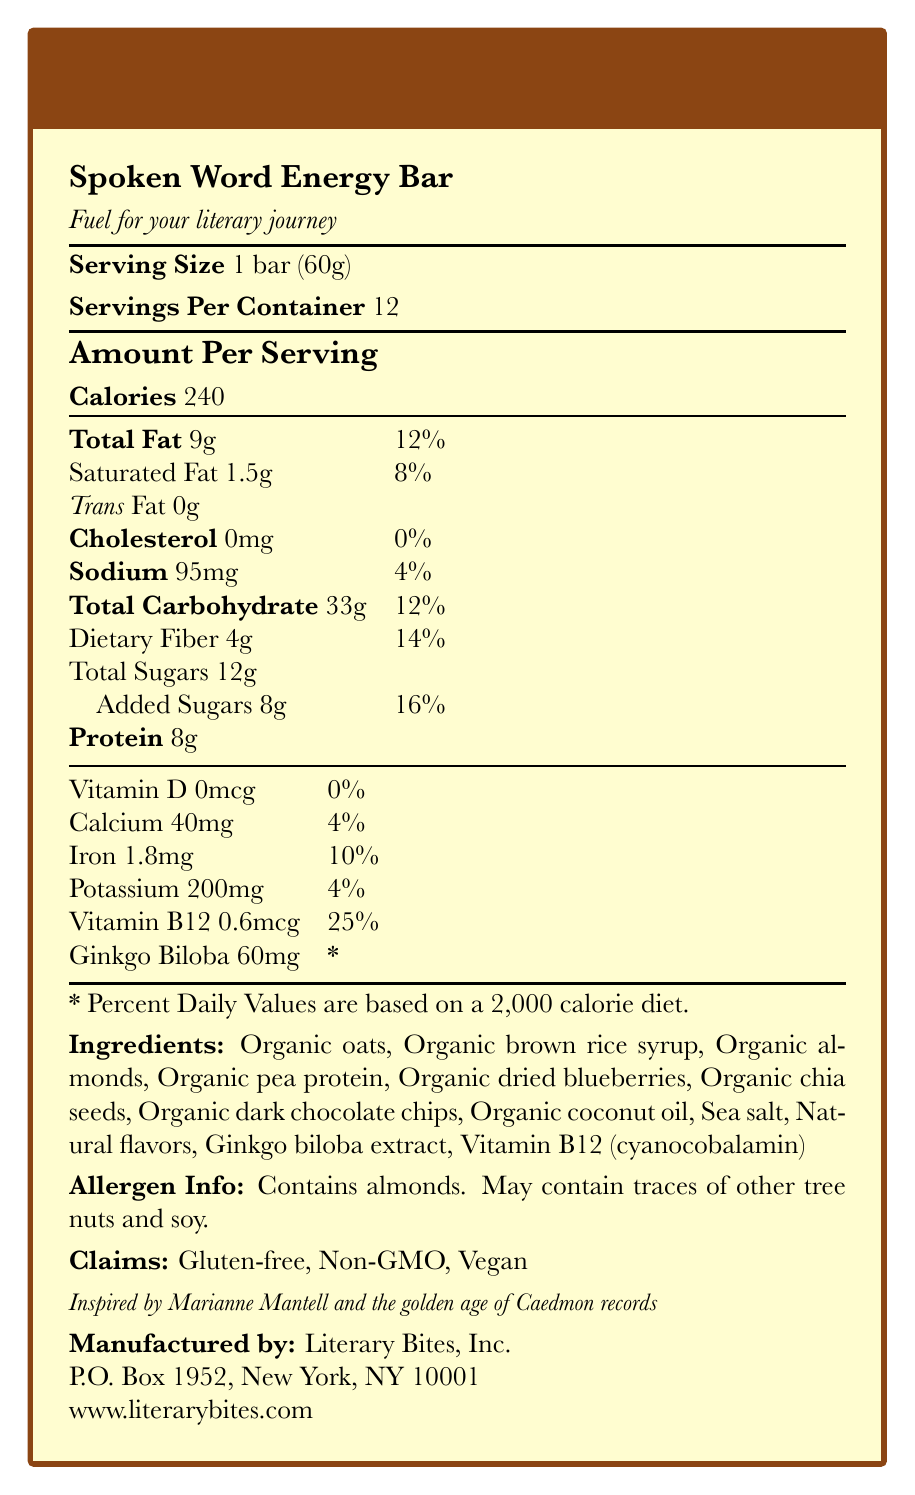who manufactures the Spoken Word Energy Bar? The document states that the manufacturer is Literary Bites, Inc.
Answer: Literary Bites, Inc. what is the serving size of the Spoken Word Energy Bar? The serving size is clearly listed as 1 bar (60g) in the document.
Answer: 1 bar (60g) how many calories are in a single serving of the Spoken Word Energy Bar? The document mentions that each serving has 240 calories.
Answer: 240 calories what is the amount of dietary fiber per serving? The document indicates that each serving contains 4g of dietary fiber.
Answer: 4g what percentage of the daily value of Vitamin B12 does one serving provide? The document states that one serving provides 25% of the daily value for Vitamin B12.
Answer: 25% how many servings are there per container? The document states that there are 12 servings per container.
Answer: 12 which of the following is NOT one of the key features mentioned in the document? A. Sustained energy release B. Brain-boosting Ginkgo biloba C. High protein content D. Antioxidant-rich blueberries While the bar does contain protein, the key features listed in the document do not explicitly highlight high protein content.
Answer: C. High protein content what is the amount of added sugars in one serving? According to the document, there are 8g of added sugars in one serving.
Answer: 8g true or false: the Spoken Word Energy Bar contains tree nuts. The allergen information states that the bar contains almonds, which are tree nuts.
Answer: True which claim is NOT made about the Spoken Word Energy Bar? A. Gluten-free B. Non-GMO C. Organic D. Vegan The document claims that the bar is Gluten-free, Non-GMO, and Vegan, but it does not claim that the product is Organic.
Answer: C. Organic describe the entire document This comprehensive description captures all the essential elements provided in the document, including nutritional information, features, ingredients, claims, and contact details.
Answer: The document is a detailed Nutrition Facts Label for the "Spoken Word Energy Bar," which is designed for audiobook enthusiasts. It includes information about serving size, servings per container, calorie content, and various nutrients. It highlights key features like sustained energy release, brain-boosting Ginkgo biloba, Vitamin B12 for cognitive function, and antioxidant-rich blueberries. The document also lists ingredients, allergen information, and product claims. Additionally, it includes a brief product description inspired by Marianne Mantell and the golden age of Caedmon records, and provides manufacturer details with contact information. what are the main ingredients of the Spoken Word Energy Bar? The document lists these as the ingredients for the energy bar.
Answer: Organic oats, Organic brown rice syrup, Organic almonds, Organic pea protein, Organic dried blueberries, Organic chia seeds, Organic dark chocolate chips, Organic coconut oil, Sea salt, Natural flavors, Ginkgo biloba extract, Vitamin B12 (cyanocobalamin) what is the daily value percentage of iron per serving? The document states that one serving contains 10% of the daily value for iron.
Answer: 10% does the Spoken Word Energy Bar contain any cholesterol? The document mentions that the bar contains 0mg of cholesterol.
Answer: No what is the contact address for the manufacturer? The contact information provided in the document is P.O. Box 1952, New York, NY 10001.
Answer: P.O. Box 1952, New York, NY 10001 how much Ginkgo biloba is in one serving of the bar? The document states that there are 60mg of Ginkgo biloba in one serving.
Answer: 60mg what is the total fat content per serving, and what percentage of the daily value does this represent? The document lists the total fat content per serving as 9g, which is 12% of the daily value.
Answer: 9g, 12% which nutrient contributes the highest percentage of the daily value per serving? A. Saturated Fat B. Dietary Fiber C. Vitamin B12 D. Iron The document states that Vitamin B12 contributes the highest percentage of the daily value at 25%.
Answer: C. Vitamin B12 can the document provide information about the effects of Ginkgo biloba on focus and memory? The document lists Ginkgo biloba as an ingredient but does not provide detailed information about its effects on focus and memory.
Answer: No, Not enough information 